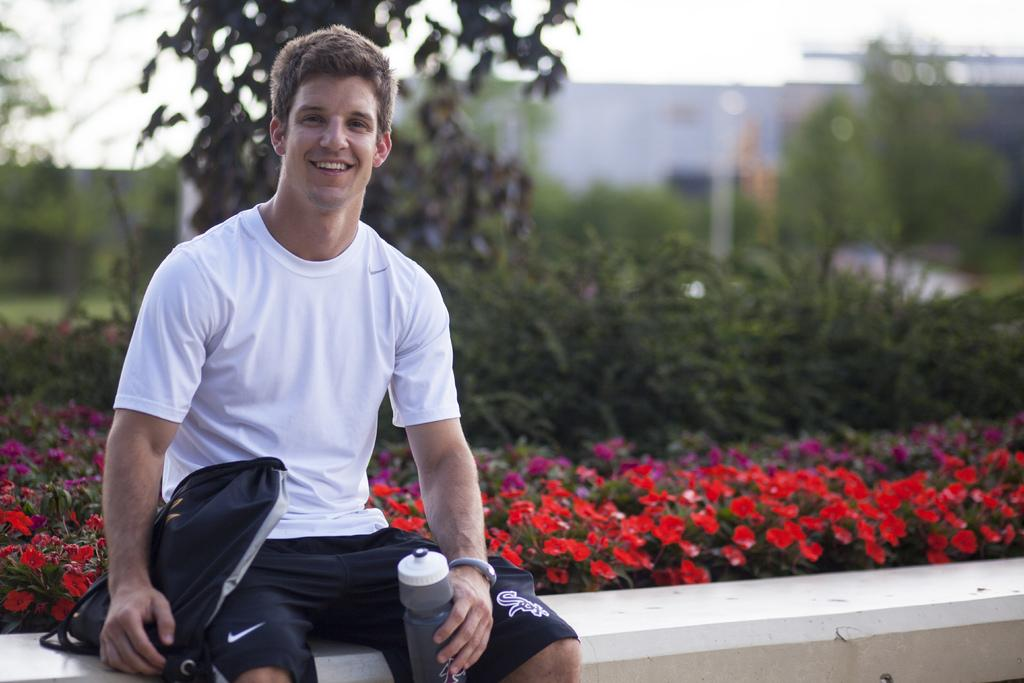What is the man doing on the left side of the image? The man is sitting on a platform on the left side of the image. What is the man holding in his hands? The man is holding a bag and a water bottle in his hands. What can be seen in the background of the image? There are plants with flowers, trees, a building, and the sky visible in the background of the image. What type of jewel can be seen hanging from the icicle in the image? There is no icicle or jewel present in the image. What type of music is being played in the background of the image? There is no music present in the image. 